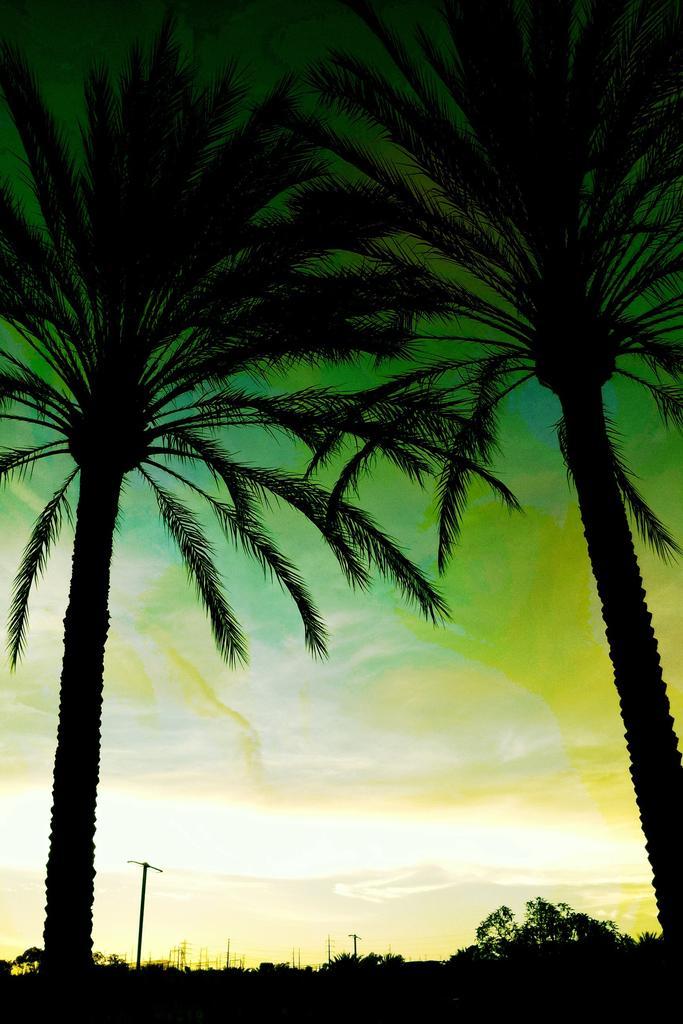Can you describe this image briefly? In this picture there are trees and poles at the bottom side of the image and there are two coconut trees on the right and left side of the image. 